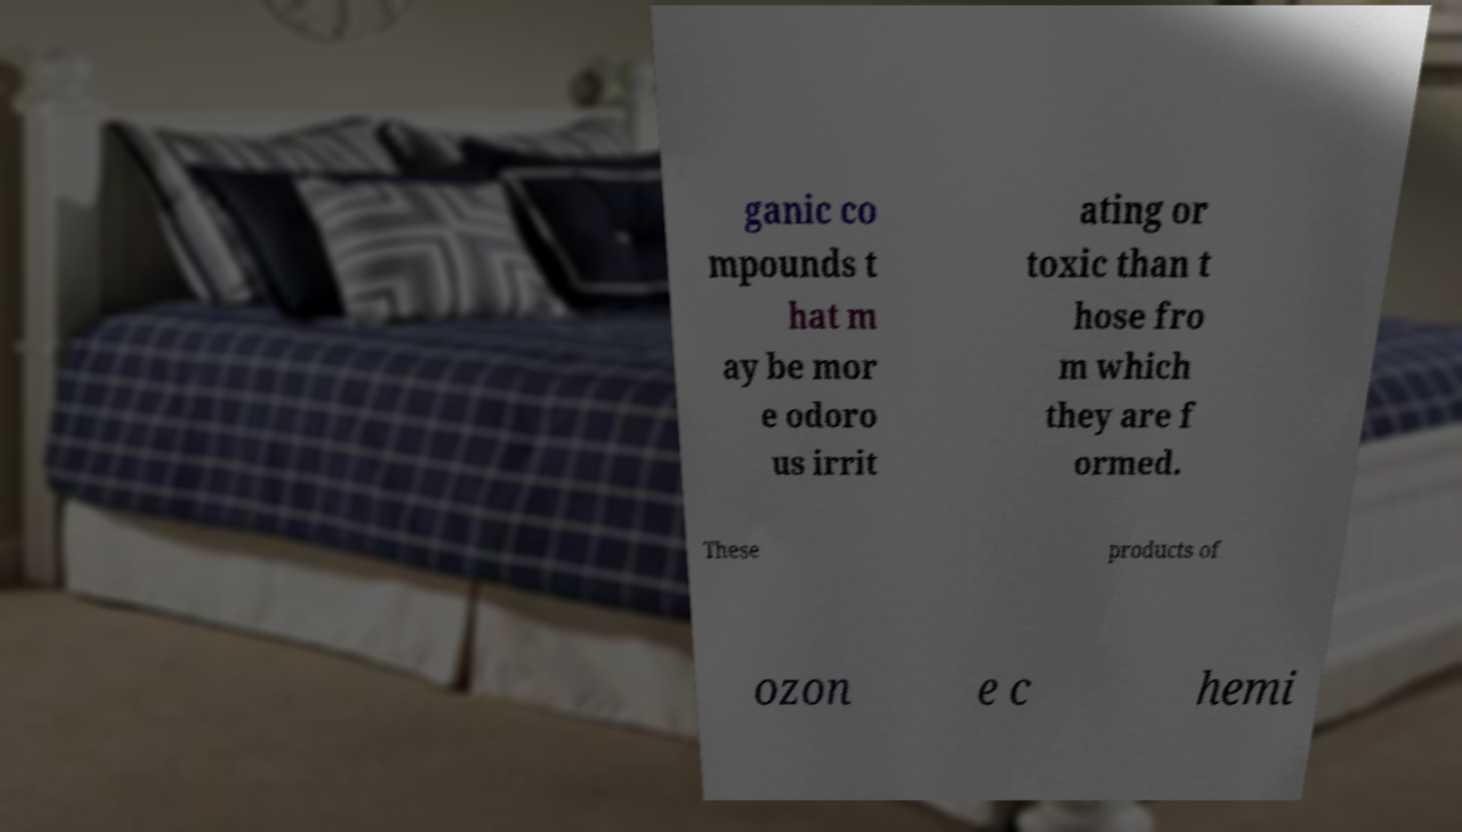Can you read and provide the text displayed in the image?This photo seems to have some interesting text. Can you extract and type it out for me? ganic co mpounds t hat m ay be mor e odoro us irrit ating or toxic than t hose fro m which they are f ormed. These products of ozon e c hemi 